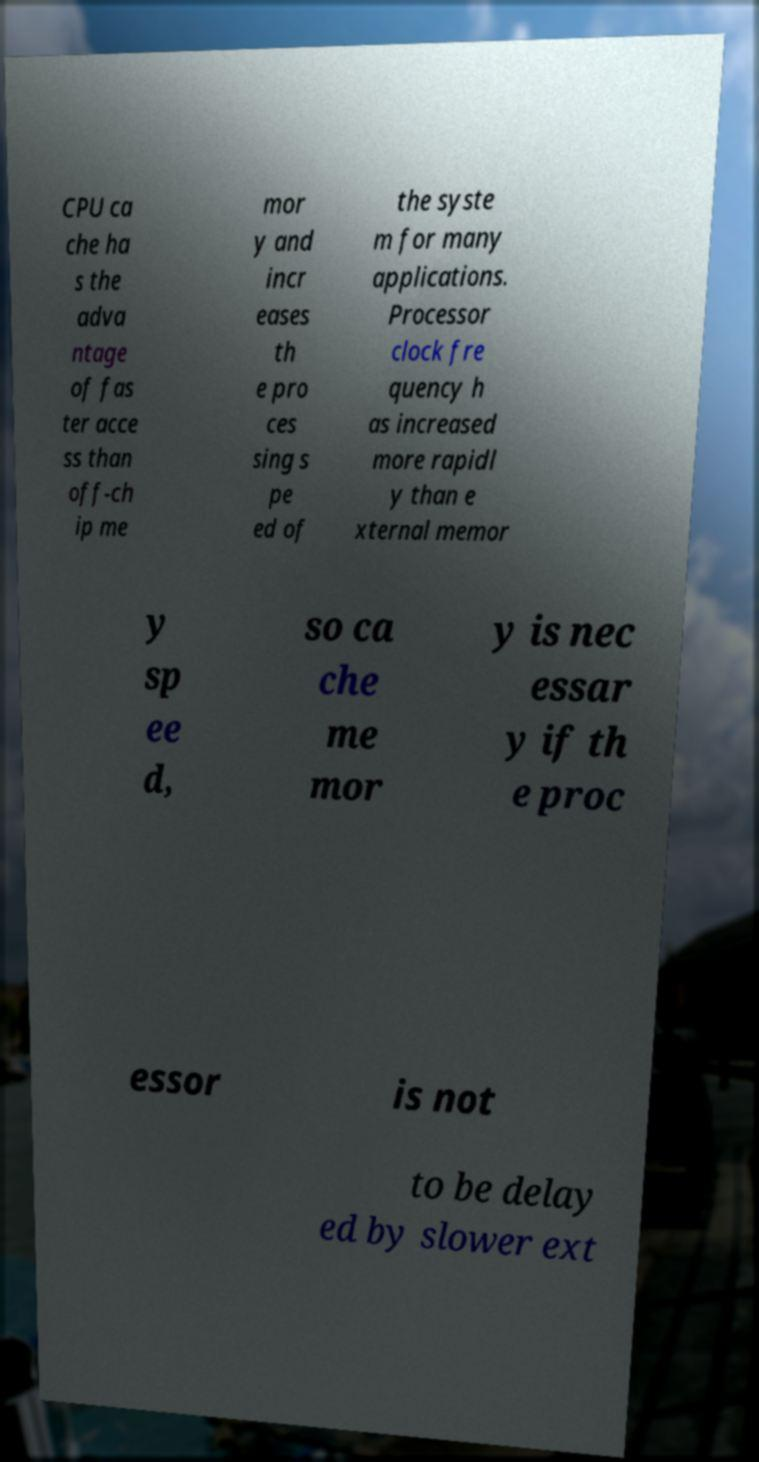For documentation purposes, I need the text within this image transcribed. Could you provide that? CPU ca che ha s the adva ntage of fas ter acce ss than off-ch ip me mor y and incr eases th e pro ces sing s pe ed of the syste m for many applications. Processor clock fre quency h as increased more rapidl y than e xternal memor y sp ee d, so ca che me mor y is nec essar y if th e proc essor is not to be delay ed by slower ext 